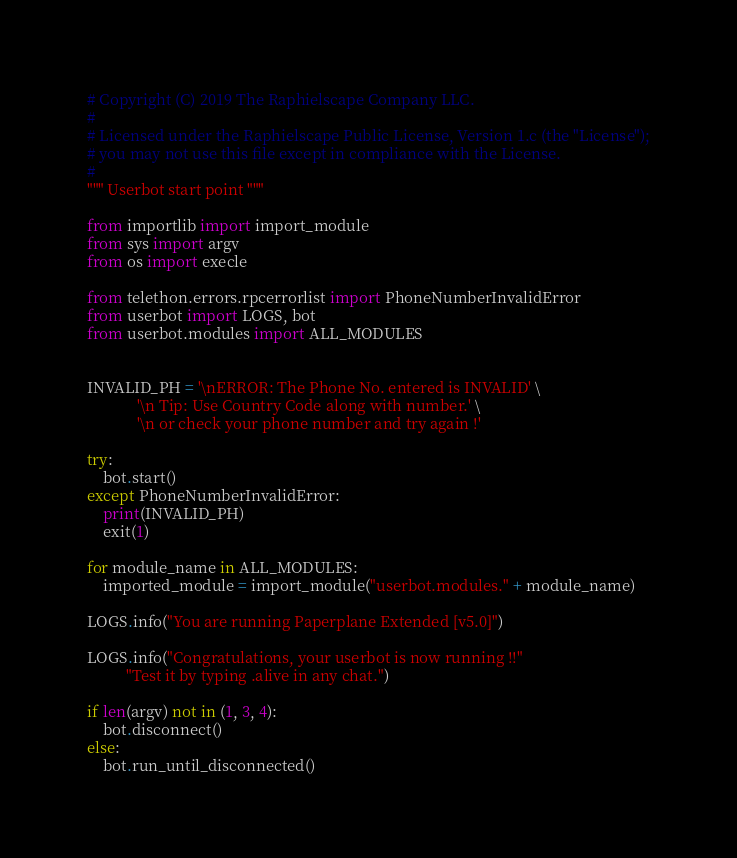Convert code to text. <code><loc_0><loc_0><loc_500><loc_500><_Python_># Copyright (C) 2019 The Raphielscape Company LLC.
#
# Licensed under the Raphielscape Public License, Version 1.c (the "License");
# you may not use this file except in compliance with the License.
#
""" Userbot start point """

from importlib import import_module
from sys import argv
from os import execle

from telethon.errors.rpcerrorlist import PhoneNumberInvalidError
from userbot import LOGS, bot
from userbot.modules import ALL_MODULES


INVALID_PH = '\nERROR: The Phone No. entered is INVALID' \
             '\n Tip: Use Country Code along with number.' \
             '\n or check your phone number and try again !'

try:
    bot.start()
except PhoneNumberInvalidError:
    print(INVALID_PH)
    exit(1)

for module_name in ALL_MODULES:
    imported_module = import_module("userbot.modules." + module_name)

LOGS.info("You are running Paperplane Extended [v5.0]")

LOGS.info("Congratulations, your userbot is now running !!"
          "Test it by typing .alive in any chat.")

if len(argv) not in (1, 3, 4):
    bot.disconnect()
else:
    bot.run_until_disconnected()</code> 